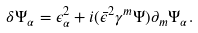<formula> <loc_0><loc_0><loc_500><loc_500>\delta \Psi _ { \alpha } = \epsilon ^ { 2 } _ { \alpha } + i ( \bar { \epsilon } ^ { 2 } \gamma ^ { m } \Psi ) \partial _ { m } \Psi _ { \alpha } .</formula> 